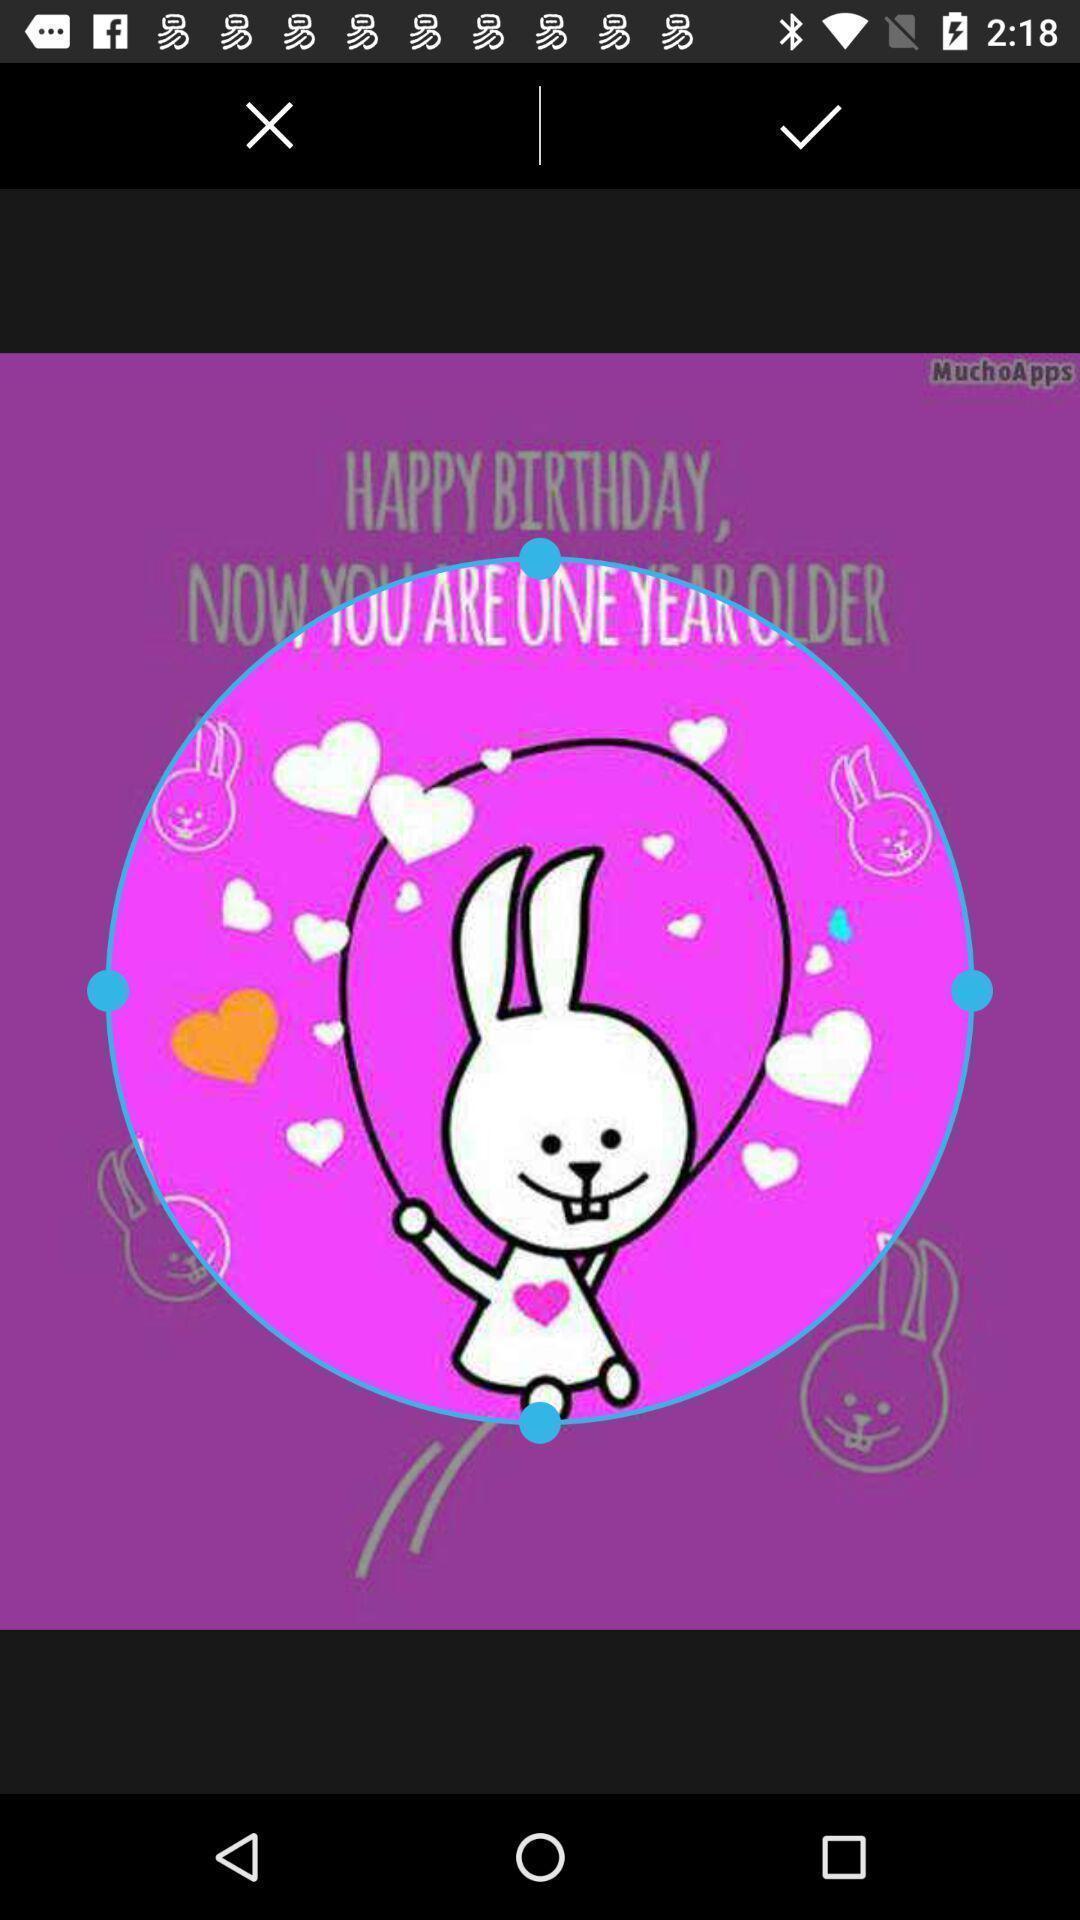Tell me about the visual elements in this screen capture. Page showing an image to crop. 